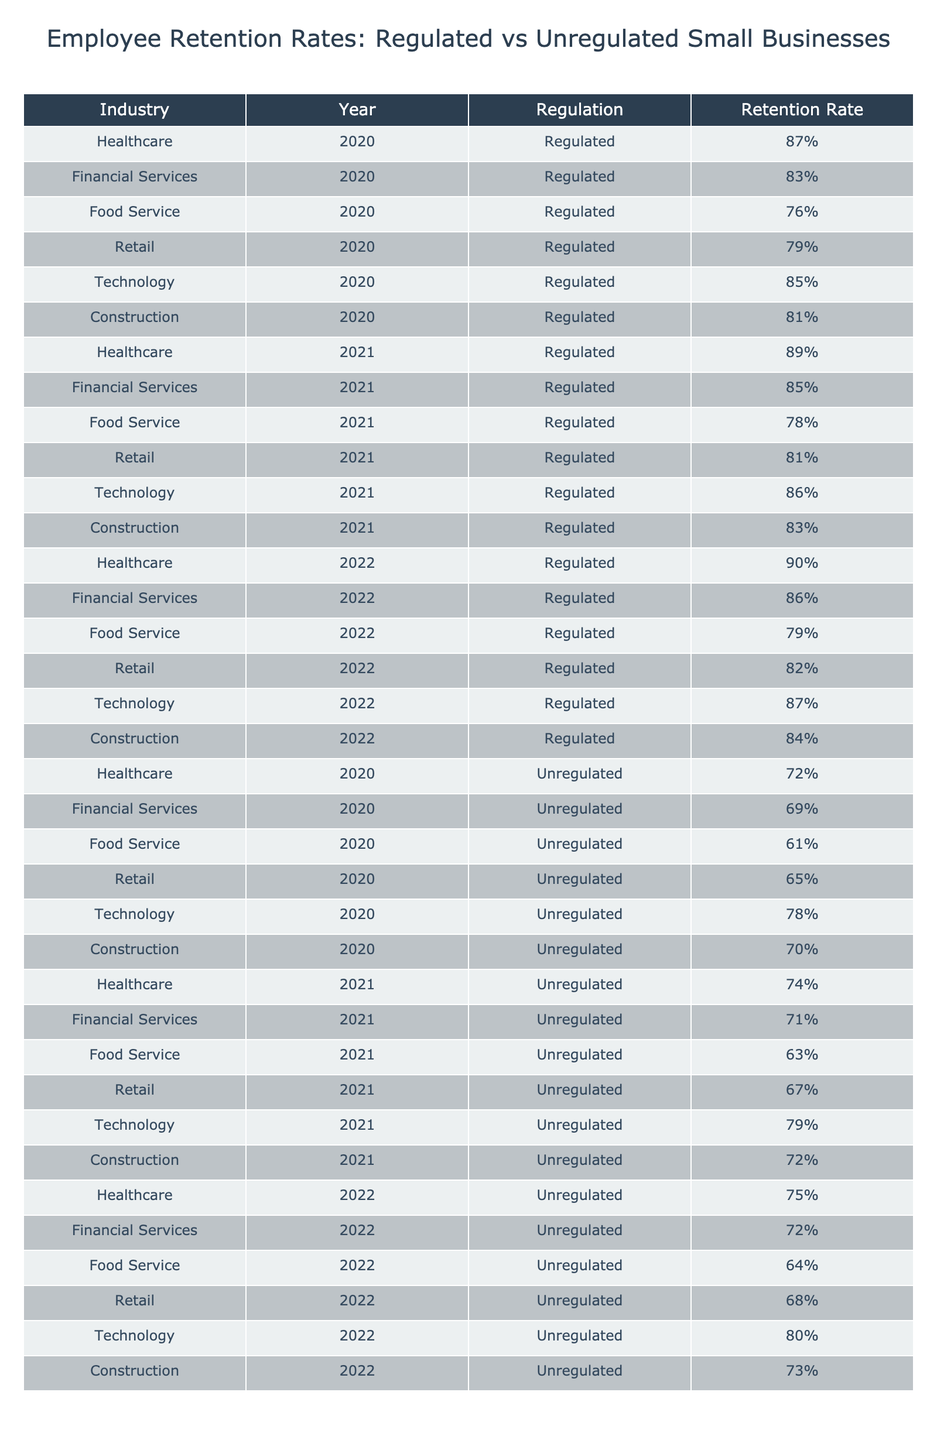What was the employee retention rate for healthcare in 2021? The table shows the employee retention rate for healthcare in 2021 as 89%.
Answer: 89% Which industry had the lowest employee retention rate in 2020? In 2020, the food service industry had the lowest retention rate at 76%.
Answer: 76% What is the difference in employee retention rates between regulated and unregulated financial services in 2022? For financial services in 2022, the regulated retention rate is 86% and the unregulated rate is 72%. The difference is 86% - 72% = 14%.
Answer: 14% Did the employee retention rate for retail increase from 2020 to 2021? The retention rate for retail in 2020 is 79%, and in 2021 it increased to 81%. Therefore, the retention rate did increase.
Answer: Yes What is the average employee retention rate for regulated industries across the years 2020 to 2022? To find the average, we add the regulated retention rates from each year: (87% + 83% + 76% + 79% + 85% + 81% + 89% + 85% + 78% + 81% + 86% + 83% + 90% + 86% + 79% + 82% + 87% + 84%) = 1,574%. There are 18 data points, so the average is 1,574% / 18 = approximately 87.444%.
Answer: 87.44% Which unregulated industry saw the highest employee retention rate in 2021? In 2021, the technology industry had the highest unregulated retention rate at 79%.
Answer: 79% How much did the employee retention rate for food service improve from 2020 to 2022? The retention rate for food service in 2020 is 76%, and in 2022 it increased to 79%. The improvement is 79% - 76% = 3%.
Answer: 3% What regulation shows a consistently higher employee retention rate across all years? Looking at the data, regulated industries consistently have higher retention rates than unregulated industries across each year shown.
Answer: Yes What is the total employee retention rate for all regulated industries combined in 2020? The total for regulated industries in 2020 is 87% + 83% + 76% + 79% + 85% + 81% = 491%.
Answer: 491% 